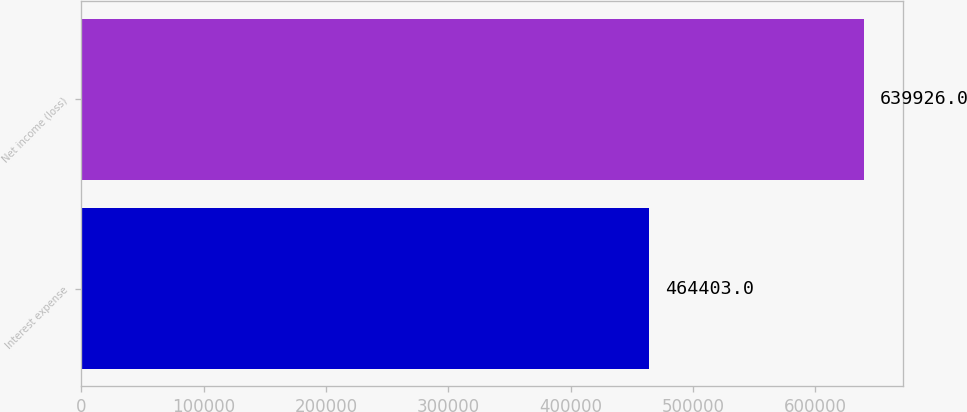Convert chart. <chart><loc_0><loc_0><loc_500><loc_500><bar_chart><fcel>Interest expense<fcel>Net income (loss)<nl><fcel>464403<fcel>639926<nl></chart> 